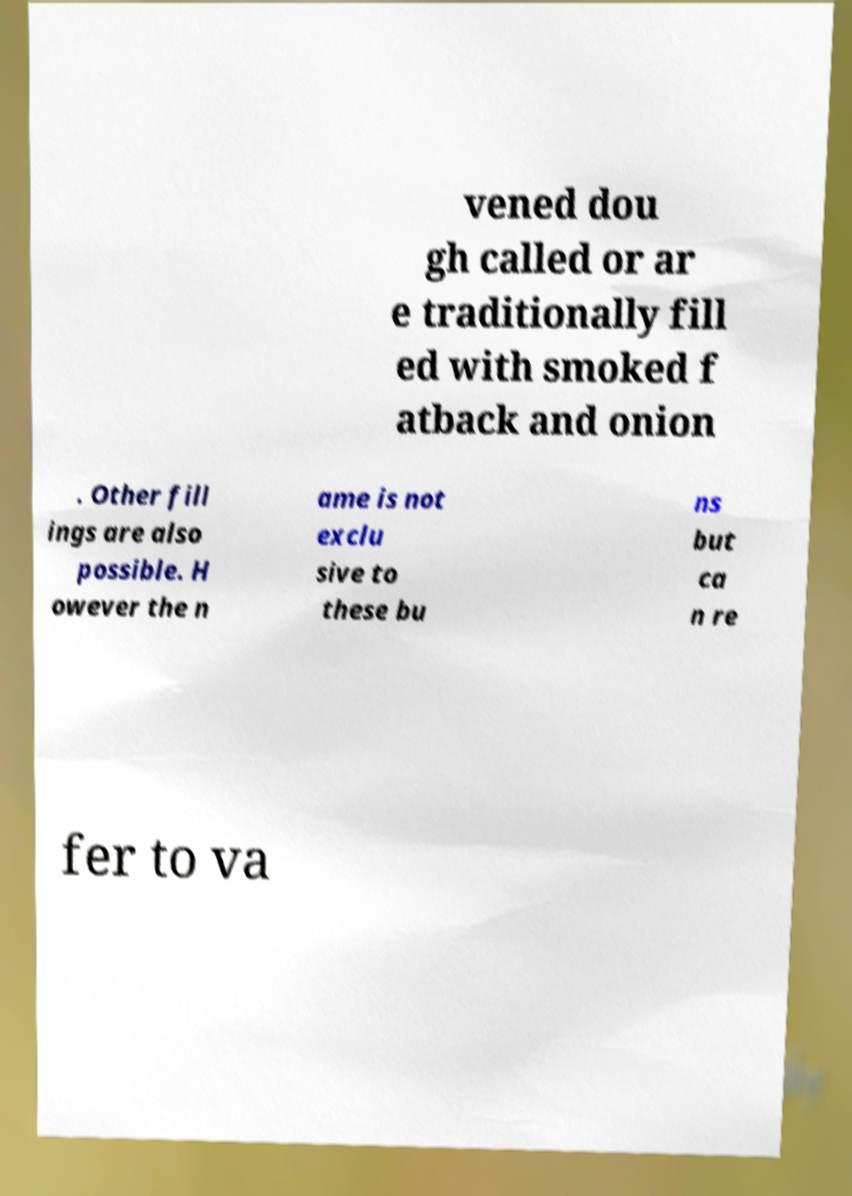Could you assist in decoding the text presented in this image and type it out clearly? vened dou gh called or ar e traditionally fill ed with smoked f atback and onion . Other fill ings are also possible. H owever the n ame is not exclu sive to these bu ns but ca n re fer to va 